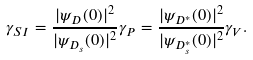Convert formula to latex. <formula><loc_0><loc_0><loc_500><loc_500>\gamma _ { S I } = \frac { | \psi _ { D } ( 0 ) | ^ { 2 } } { | \psi _ { D _ { s } } ( 0 ) | ^ { 2 } } \gamma _ { P } = \frac { | \psi _ { D ^ { * } } ( 0 ) | ^ { 2 } } { | \psi _ { D _ { s } ^ { * } } ( 0 ) | ^ { 2 } } \gamma _ { V } .</formula> 